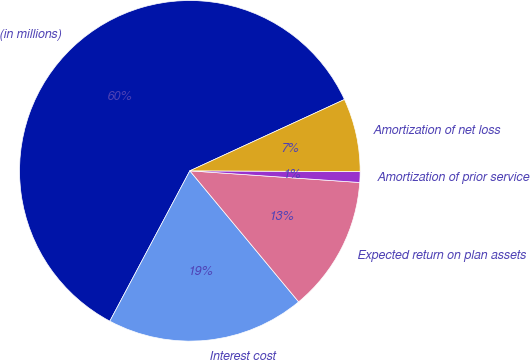Convert chart. <chart><loc_0><loc_0><loc_500><loc_500><pie_chart><fcel>(in millions)<fcel>Interest cost<fcel>Expected return on plan assets<fcel>Amortization of prior service<fcel>Amortization of net loss<nl><fcel>60.33%<fcel>18.81%<fcel>12.88%<fcel>1.02%<fcel>6.95%<nl></chart> 